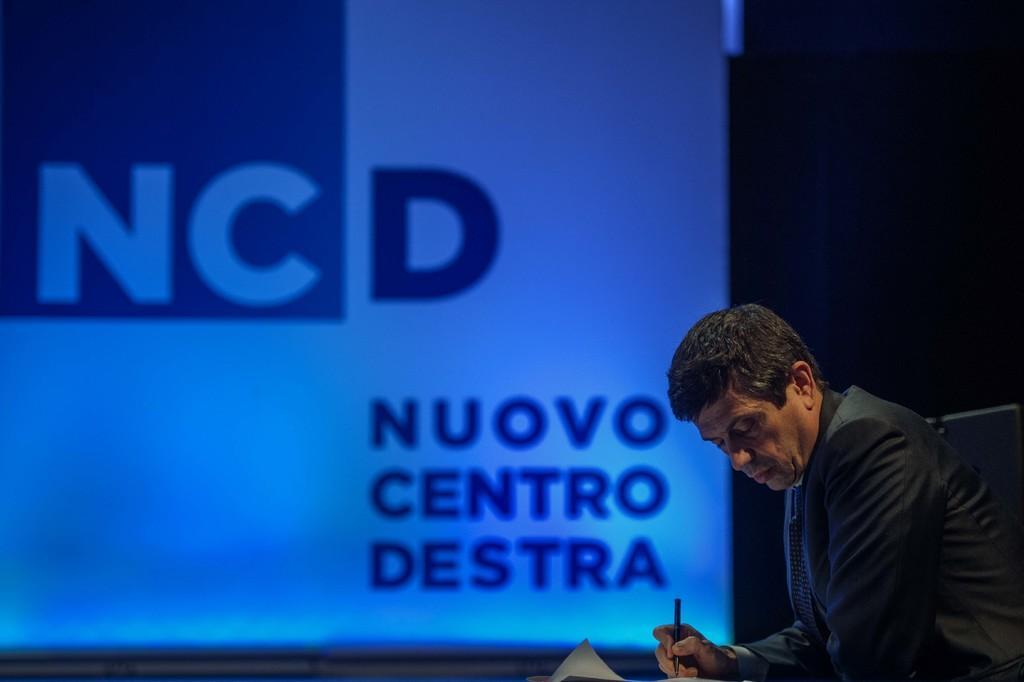Please provide a concise description of this image. In this image I can see a person sitting and holding pen. The person is wearing black dress, background I can see a projector screen. 